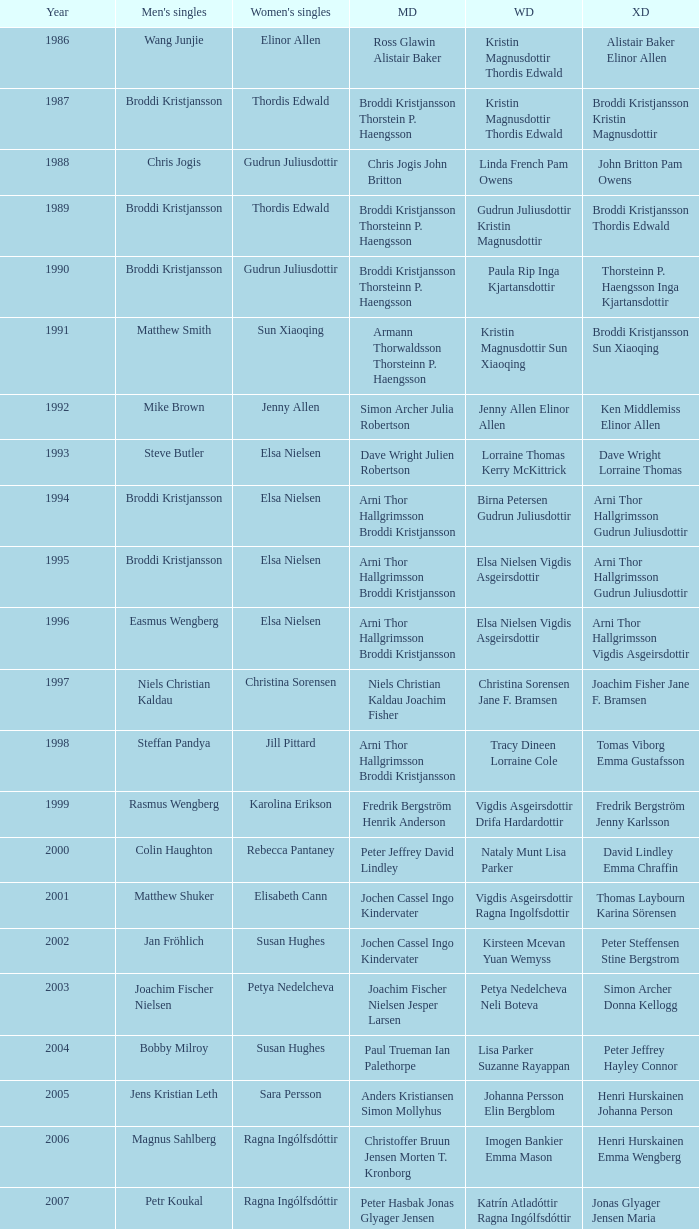In which women's doubles did Wang Junjie play men's singles? Kristin Magnusdottir Thordis Edwald. 